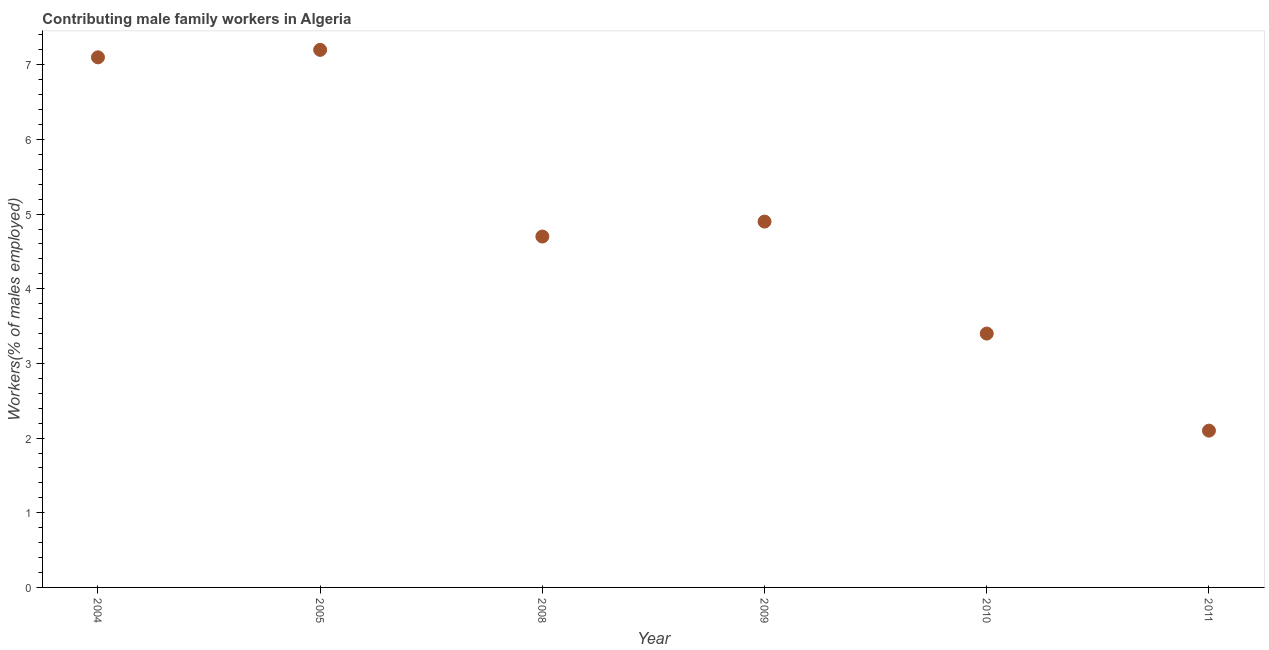What is the contributing male family workers in 2004?
Provide a short and direct response. 7.1. Across all years, what is the maximum contributing male family workers?
Provide a succinct answer. 7.2. Across all years, what is the minimum contributing male family workers?
Keep it short and to the point. 2.1. In which year was the contributing male family workers maximum?
Ensure brevity in your answer.  2005. In which year was the contributing male family workers minimum?
Make the answer very short. 2011. What is the sum of the contributing male family workers?
Give a very brief answer. 29.4. What is the difference between the contributing male family workers in 2004 and 2010?
Offer a very short reply. 3.7. What is the average contributing male family workers per year?
Your answer should be very brief. 4.9. What is the median contributing male family workers?
Your response must be concise. 4.8. In how many years, is the contributing male family workers greater than 4.4 %?
Provide a short and direct response. 4. Do a majority of the years between 2004 and 2010 (inclusive) have contributing male family workers greater than 2.2 %?
Your answer should be very brief. Yes. What is the ratio of the contributing male family workers in 2008 to that in 2010?
Ensure brevity in your answer.  1.38. Is the contributing male family workers in 2008 less than that in 2010?
Offer a terse response. No. Is the difference between the contributing male family workers in 2004 and 2005 greater than the difference between any two years?
Ensure brevity in your answer.  No. What is the difference between the highest and the second highest contributing male family workers?
Give a very brief answer. 0.1. Is the sum of the contributing male family workers in 2004 and 2005 greater than the maximum contributing male family workers across all years?
Offer a very short reply. Yes. What is the difference between the highest and the lowest contributing male family workers?
Give a very brief answer. 5.1. How many dotlines are there?
Your answer should be very brief. 1. How many years are there in the graph?
Offer a very short reply. 6. What is the difference between two consecutive major ticks on the Y-axis?
Give a very brief answer. 1. Are the values on the major ticks of Y-axis written in scientific E-notation?
Provide a succinct answer. No. Does the graph contain any zero values?
Your answer should be compact. No. Does the graph contain grids?
Provide a succinct answer. No. What is the title of the graph?
Offer a very short reply. Contributing male family workers in Algeria. What is the label or title of the Y-axis?
Give a very brief answer. Workers(% of males employed). What is the Workers(% of males employed) in 2004?
Offer a very short reply. 7.1. What is the Workers(% of males employed) in 2005?
Your answer should be compact. 7.2. What is the Workers(% of males employed) in 2008?
Keep it short and to the point. 4.7. What is the Workers(% of males employed) in 2009?
Your response must be concise. 4.9. What is the Workers(% of males employed) in 2010?
Offer a terse response. 3.4. What is the Workers(% of males employed) in 2011?
Provide a short and direct response. 2.1. What is the difference between the Workers(% of males employed) in 2004 and 2008?
Provide a succinct answer. 2.4. What is the difference between the Workers(% of males employed) in 2004 and 2009?
Make the answer very short. 2.2. What is the difference between the Workers(% of males employed) in 2005 and 2008?
Your response must be concise. 2.5. What is the difference between the Workers(% of males employed) in 2008 and 2009?
Your answer should be very brief. -0.2. What is the difference between the Workers(% of males employed) in 2008 and 2010?
Keep it short and to the point. 1.3. What is the difference between the Workers(% of males employed) in 2009 and 2011?
Offer a very short reply. 2.8. What is the difference between the Workers(% of males employed) in 2010 and 2011?
Offer a very short reply. 1.3. What is the ratio of the Workers(% of males employed) in 2004 to that in 2005?
Your answer should be very brief. 0.99. What is the ratio of the Workers(% of males employed) in 2004 to that in 2008?
Make the answer very short. 1.51. What is the ratio of the Workers(% of males employed) in 2004 to that in 2009?
Keep it short and to the point. 1.45. What is the ratio of the Workers(% of males employed) in 2004 to that in 2010?
Provide a short and direct response. 2.09. What is the ratio of the Workers(% of males employed) in 2004 to that in 2011?
Your response must be concise. 3.38. What is the ratio of the Workers(% of males employed) in 2005 to that in 2008?
Keep it short and to the point. 1.53. What is the ratio of the Workers(% of males employed) in 2005 to that in 2009?
Ensure brevity in your answer.  1.47. What is the ratio of the Workers(% of males employed) in 2005 to that in 2010?
Your answer should be very brief. 2.12. What is the ratio of the Workers(% of males employed) in 2005 to that in 2011?
Ensure brevity in your answer.  3.43. What is the ratio of the Workers(% of males employed) in 2008 to that in 2010?
Your answer should be very brief. 1.38. What is the ratio of the Workers(% of males employed) in 2008 to that in 2011?
Ensure brevity in your answer.  2.24. What is the ratio of the Workers(% of males employed) in 2009 to that in 2010?
Your answer should be very brief. 1.44. What is the ratio of the Workers(% of males employed) in 2009 to that in 2011?
Offer a terse response. 2.33. What is the ratio of the Workers(% of males employed) in 2010 to that in 2011?
Your answer should be very brief. 1.62. 